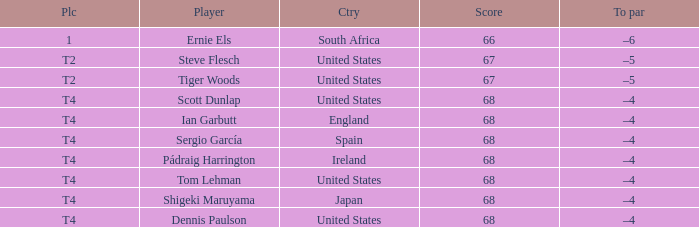What is T2 Place Player Steve Flesch's Score? 67.0. 